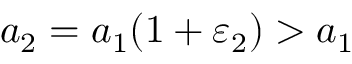Convert formula to latex. <formula><loc_0><loc_0><loc_500><loc_500>a _ { 2 } = a _ { 1 } ( 1 + \varepsilon _ { 2 } ) > a _ { 1 }</formula> 